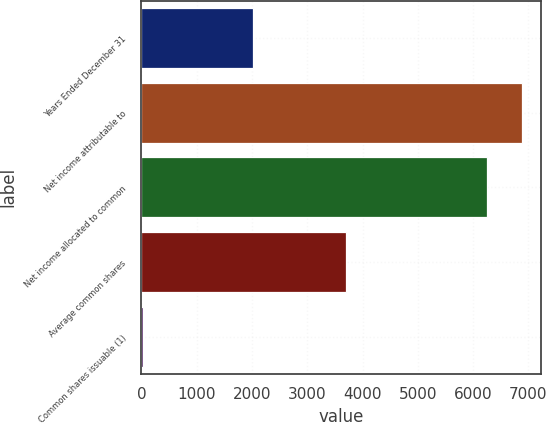<chart> <loc_0><loc_0><loc_500><loc_500><bar_chart><fcel>Years Ended December 31<fcel>Net income attributable to<fcel>Net income allocated to common<fcel>Average common shares<fcel>Common shares issuable (1)<nl><fcel>2011<fcel>6881.9<fcel>6257<fcel>3695.9<fcel>23<nl></chart> 